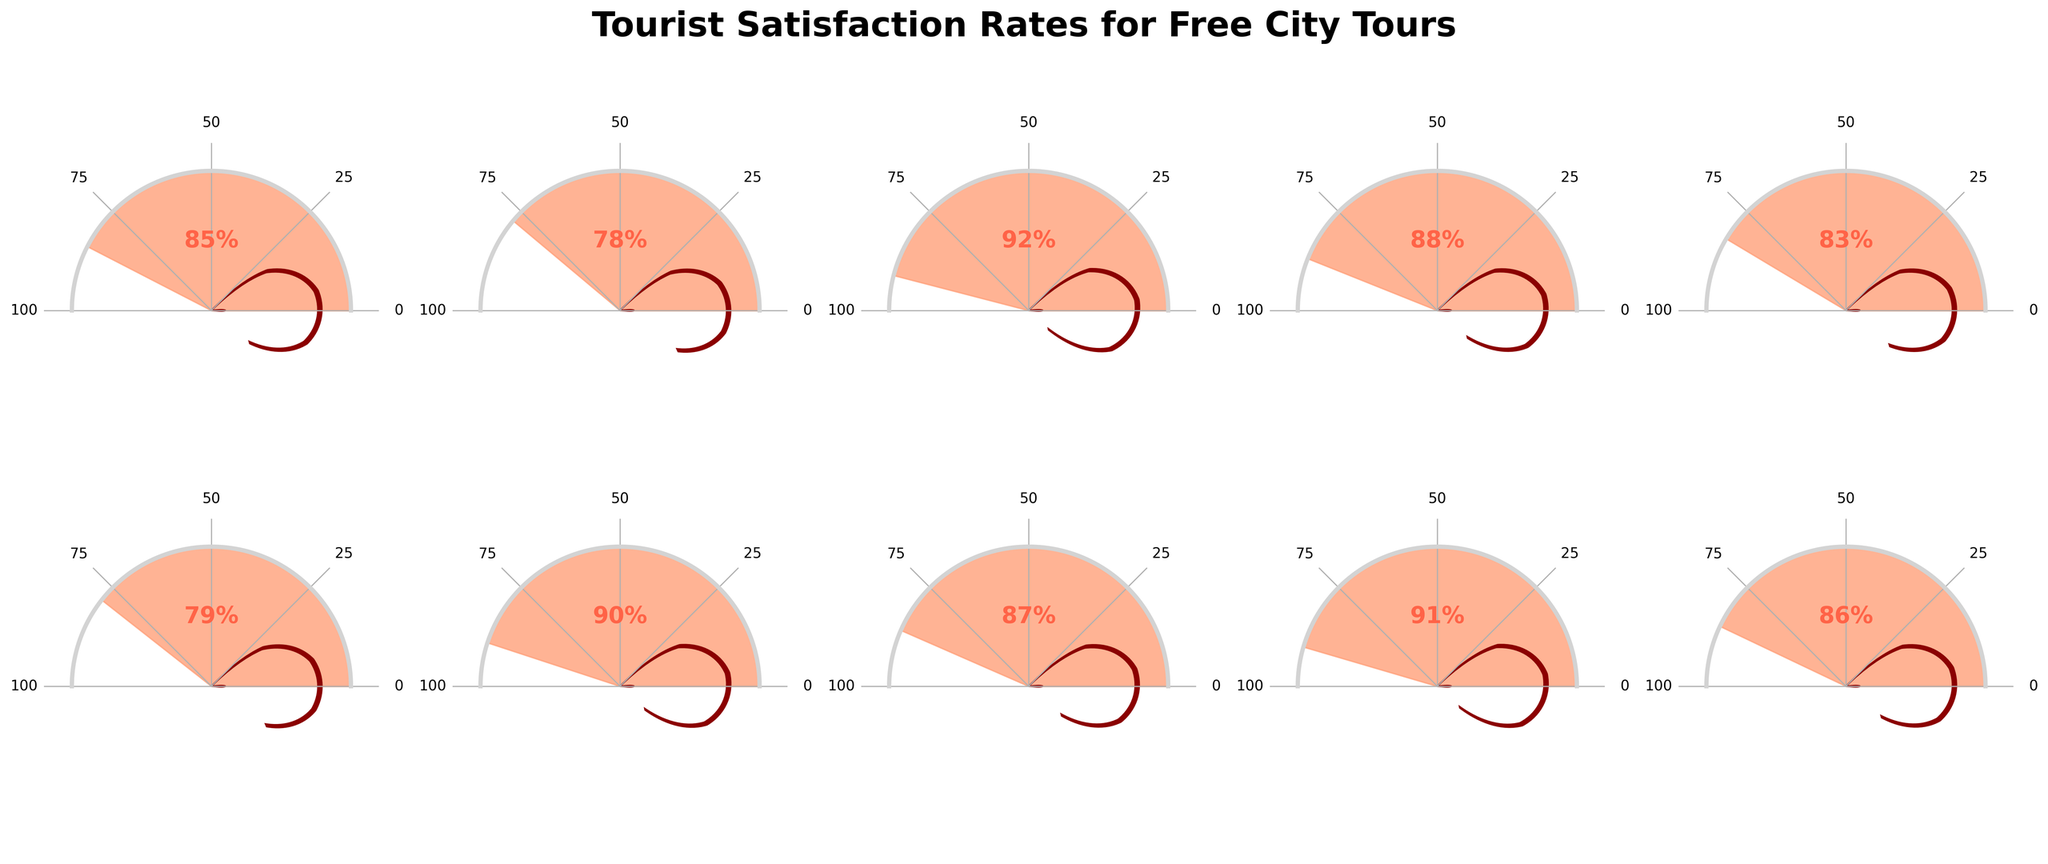What is the highest tourist satisfaction rate among the cities? To find the highest satisfaction rate, scan all the values in the figure. The highest value is 92%, which corresponds to Rome.
Answer: 92% What is the title of the figure? The title is usually found at the top of the figure. It is "Tourist Satisfaction Rates for Free City Tours".
Answer: Tourist Satisfaction Rates for Free City Tours How many cities are represented in the figure? Count the number of gauge charts shown. There are 10 gauge charts, each representing a different city.
Answer: 10 Which city has a satisfaction rate of 78%? Look for the gauge chart with a satisfaction rate of 78%. Paris has this rate.
Answer: Paris How many cities have a satisfaction rate above 85%? Count the number of gauge charts where the satisfaction rate is above 85%. There are 6 cities: Rome (92%), Prague (90%), Lisbon (91%), Vienna (87%), Barcelona (88%), and Budapest (86%).
Answer: 6 Which city has the lowest tourist satisfaction rate? Identify the lowest percentage among the satisfaction rates. The lowest rate is 78% for Paris.
Answer: Paris What is the average satisfaction rate of the cities represented in the figure? Add all the satisfaction rates together and divide by the number of cities: (85 + 78 + 92 + 88 + 83 + 79 + 90 + 87 + 91 + 86) / 10 = 85.9%.
Answer: 85.9% Which city has a higher satisfaction rate: Amsterdam or Berlin? Compare the satisfaction rates of Amsterdam (83%) and Berlin (79%). Amsterdam has a higher rate.
Answer: Amsterdam What is the combined satisfaction rate of London and Budapest? Add the satisfaction rates of London (85%) and Budapest (86%): 85 + 86 = 171%.
Answer: 171% Is the satisfaction rate of Prague higher than Vienna? Compare the satisfaction rates of Prague (90%) and Vienna (87%). Prague has a higher rate.
Answer: Yes 